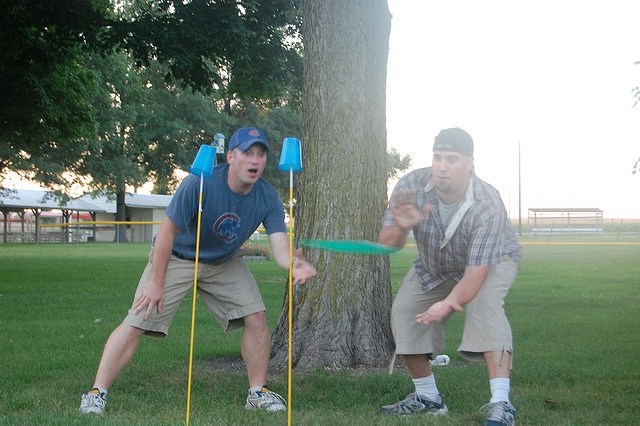Describe the objects in this image and their specific colors. I can see people in black, darkgray, gray, and lightgray tones, people in black, darkgray, blue, and gray tones, frisbee in black and teal tones, cup in black, lightblue, and teal tones, and cup in black, lightblue, and teal tones in this image. 